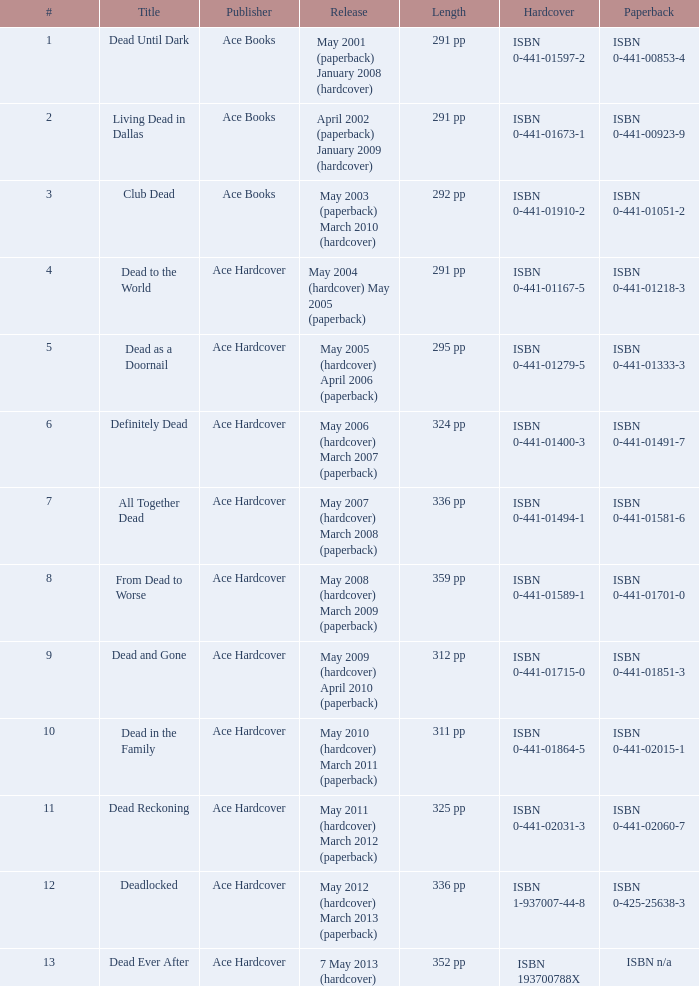How many publishers published isbn 193700788x? 1.0. 